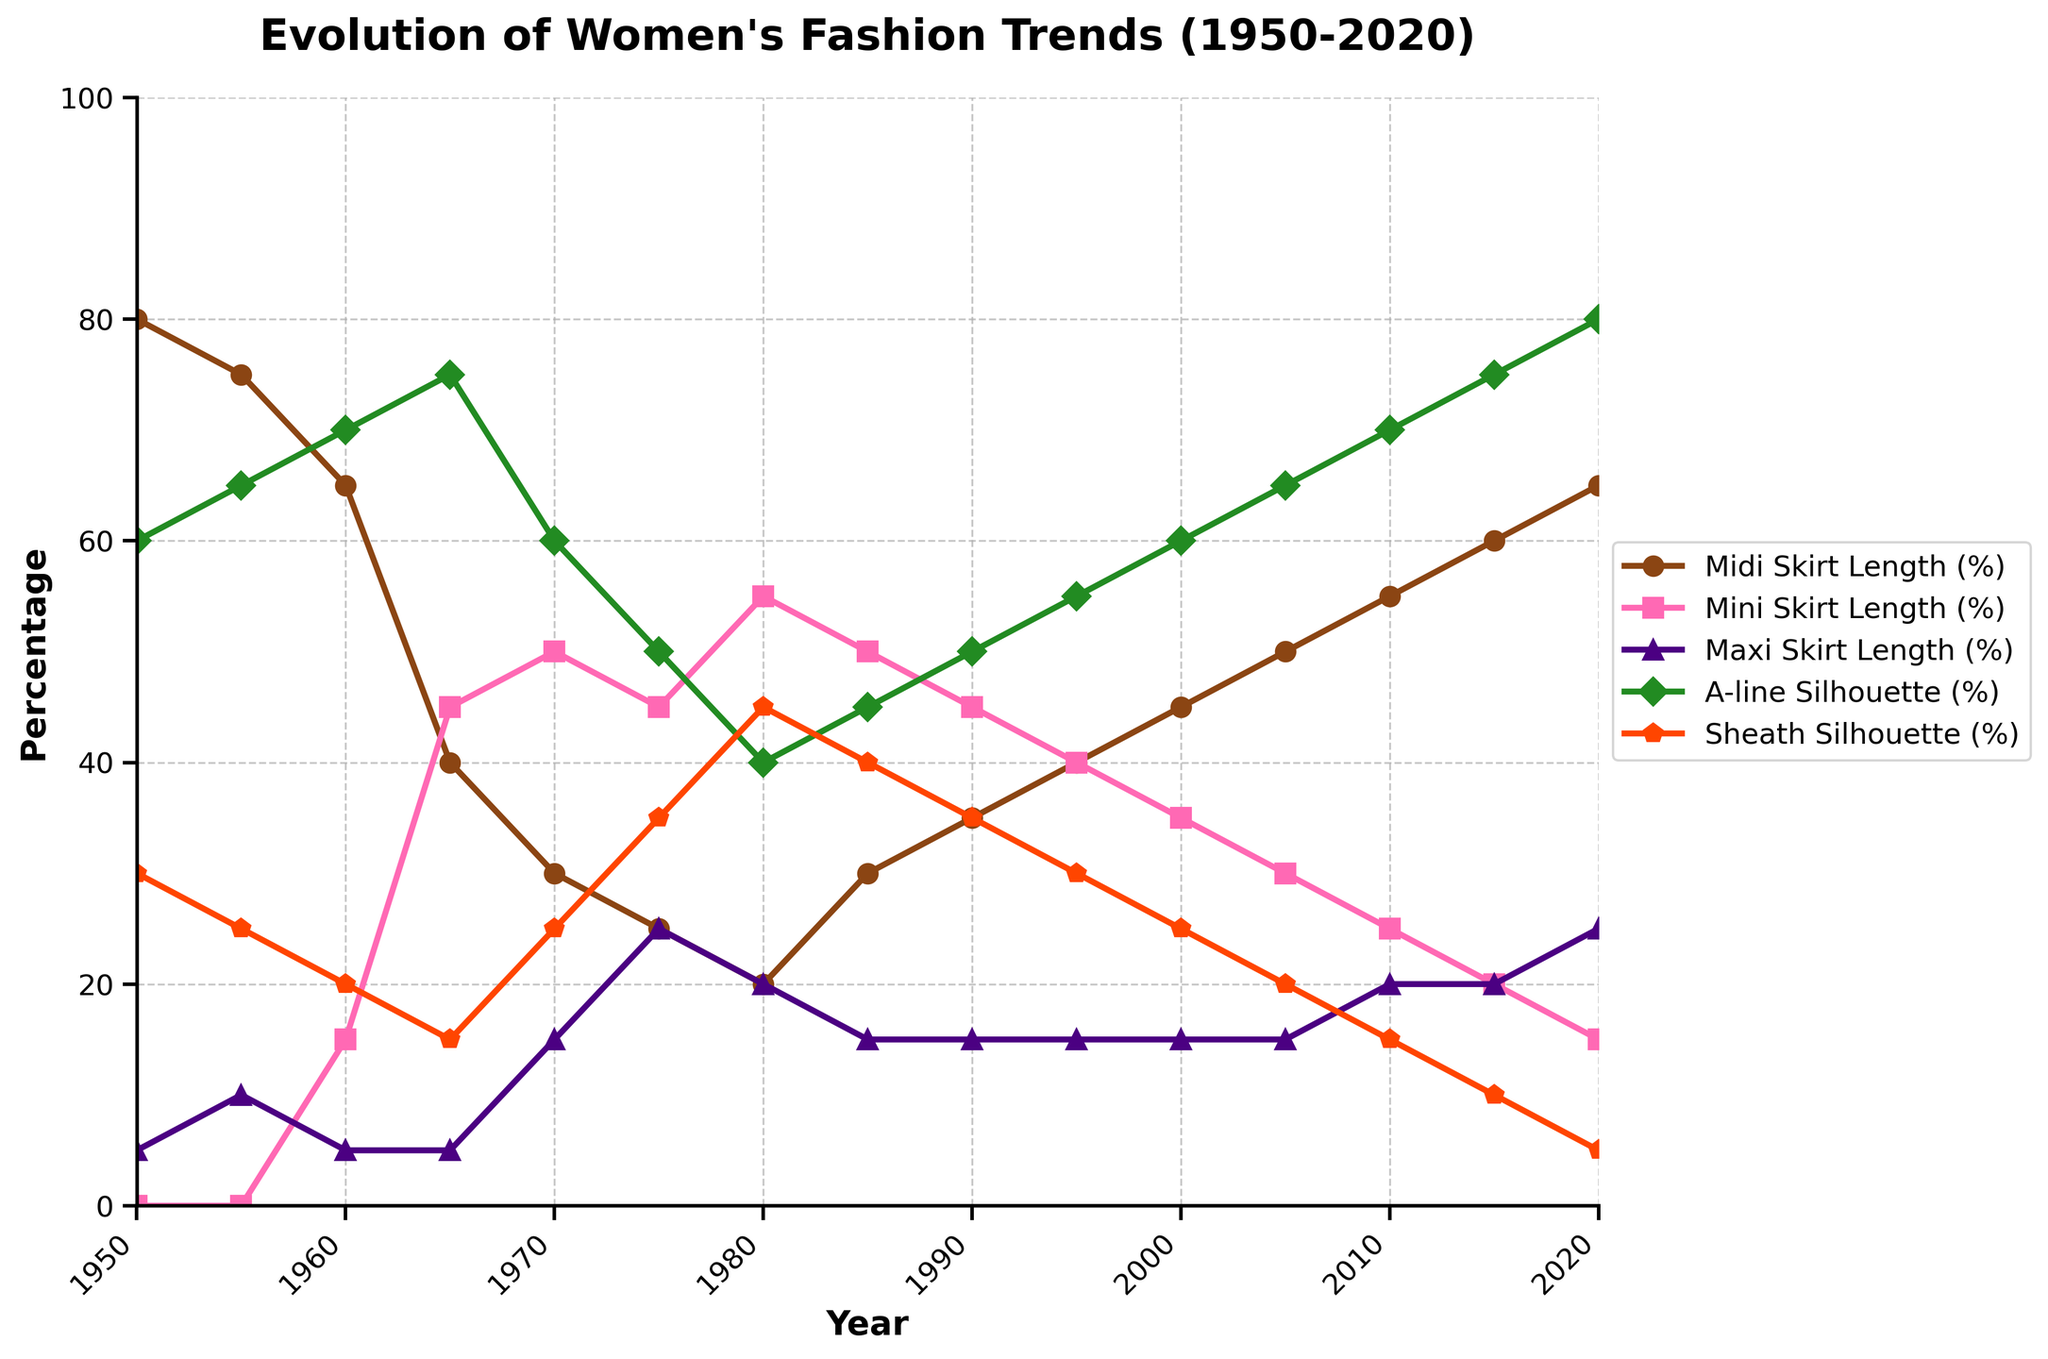What year did Mini Skirt Length peak? Observing the line representing Mini Skirt Length, it reaches its highest point around 1965 and 1970.
Answer: 1970 Which silhouette has the highest percentage in 2020? By looking at the 2020 data point, the A-line Silhouette has the highest value at 80%.
Answer: A-line Silhouette What is the difference in percentage between Midi Skirt Length and Maxi Skirt Length in 1980? In 1980, Midi Skirt Length is at 20% and Maxi Skirt Length is at 20%, so the difference is 0%.
Answer: 0% In which year is the percentage of Sheath Silhouette equal to the percentage of Maxi Skirt Length? Identifying the year when the two lines intersect or have the same height, the intersection occurs at around 1970, both having 15%.
Answer: 1970 Which type of skirt length shows a steady increase from 1950 to 2020? Observing the trends, Midi Skirt Length shows a steady increase throughout the years.
Answer: Midi Skirt Length How does the percentage of A-line Silhouette change from 1950 to 2020? From the chart, the percentage of A-line Silhouette starts at 60% in 1950 and mostly increases, reaching 80% in 2020.
Answer: Increases What is the combined percentage of Mini and Maxi Skirt Length in 1975? Adding the percentages of Mini (45%) and Maxi Skirt Length (25%) in 1975: 45% + 25% = 70%
Answer: 70% Which year shows the highest percentage for Sheath Silhouette? The Sheath Silhouette reaches its peak around 1980 at 45%.
Answer: 1980 In which year do Midi Skirt Length and Mini Skirt Length have the same percentage? The lines for Midi Skirt Length and Mini Skirt Length intersect around 1990, both at 35%.
Answer: 1990 